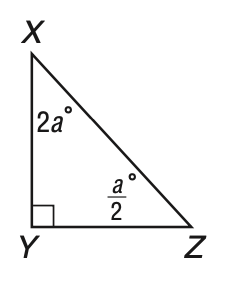Answer the mathemtical geometry problem and directly provide the correct option letter.
Question: In the triangle, what is the measure of \angle Z?
Choices: A: 18 B: 24 C: 72 D: 90 A 